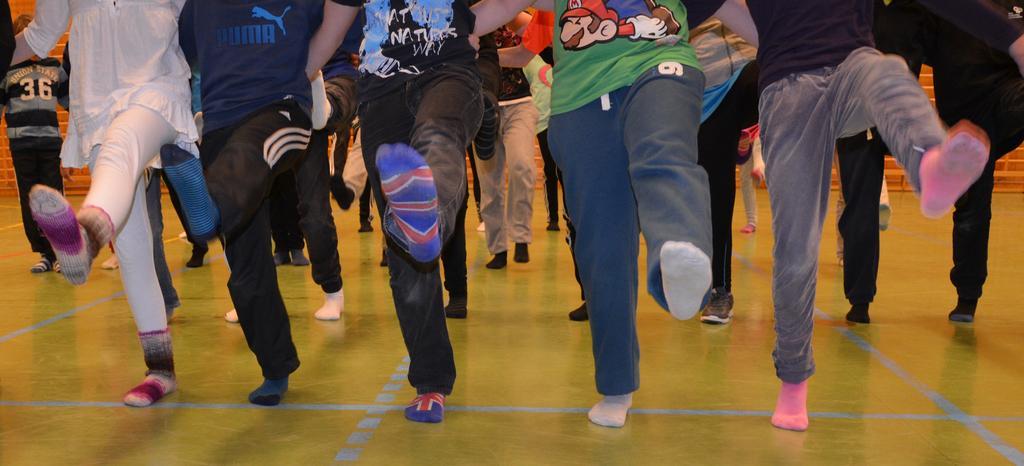How would you summarize this image in a sentence or two? In this image we can see few persons legs on the floor and they are in motion. In the background we can see few persons are standing and there is a brick wall. 